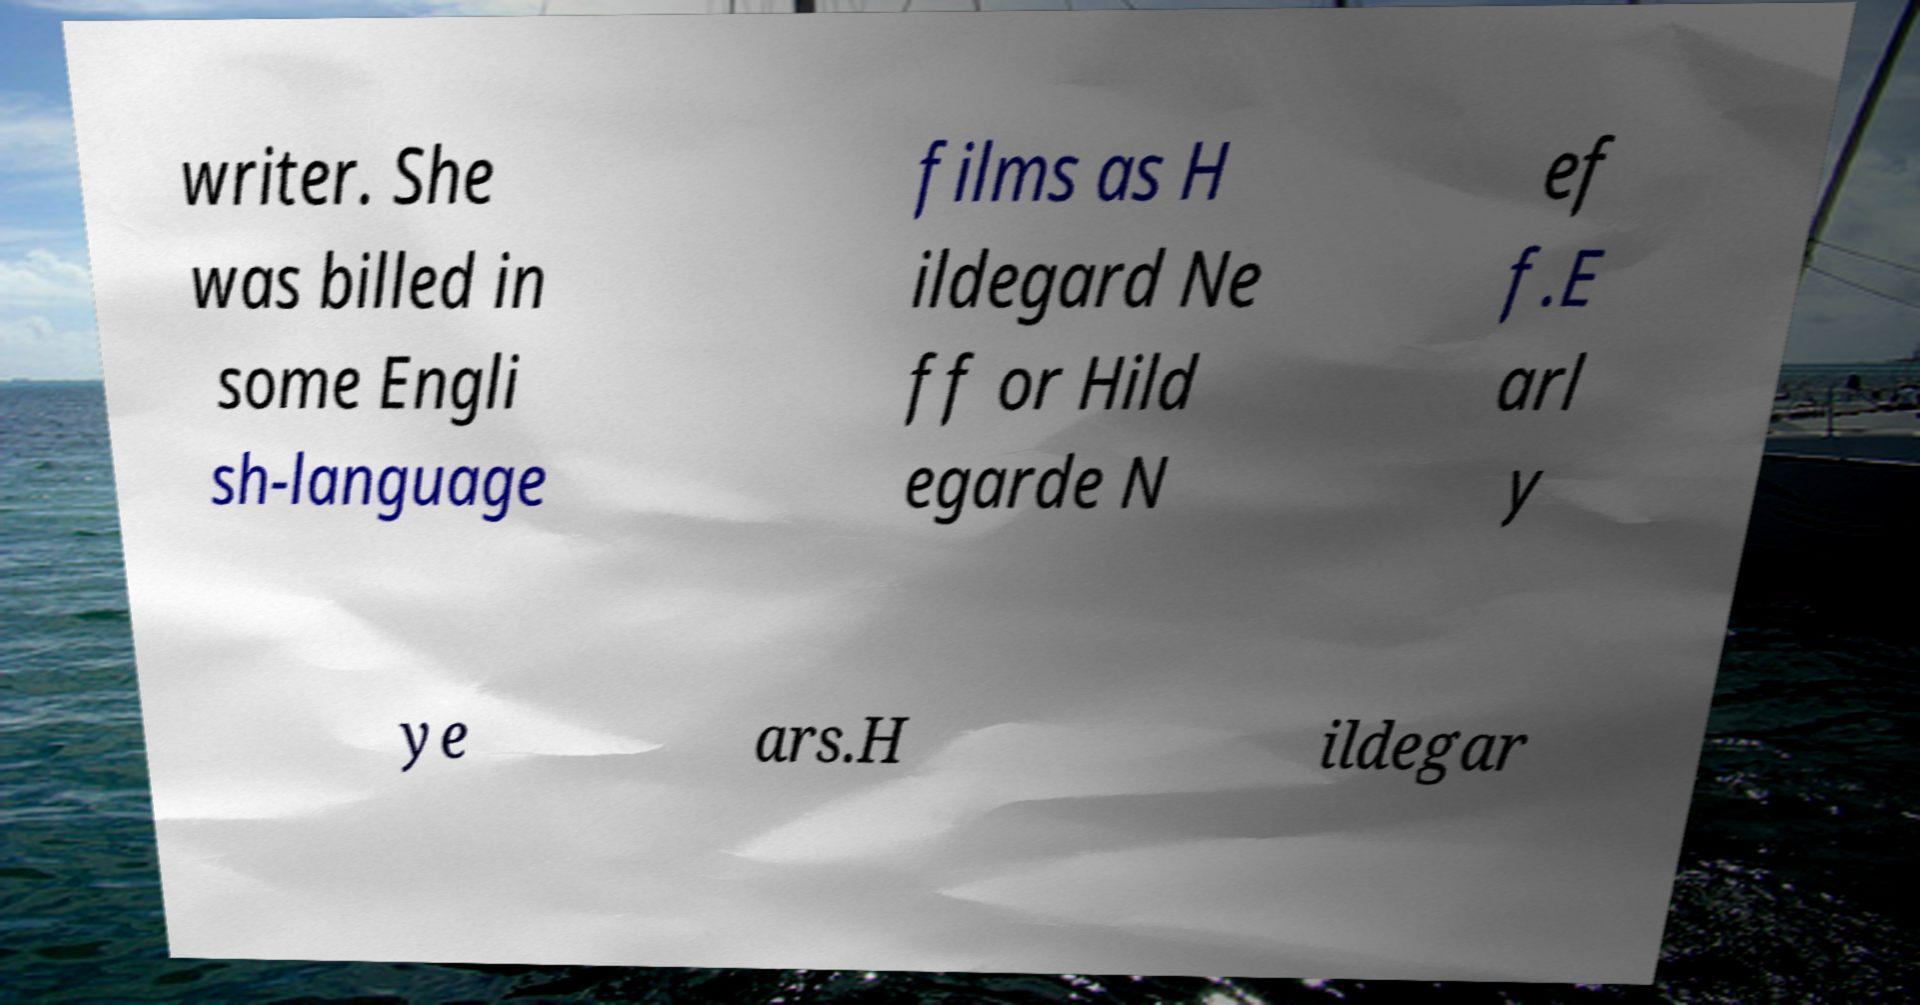For documentation purposes, I need the text within this image transcribed. Could you provide that? writer. She was billed in some Engli sh-language films as H ildegard Ne ff or Hild egarde N ef f.E arl y ye ars.H ildegar 